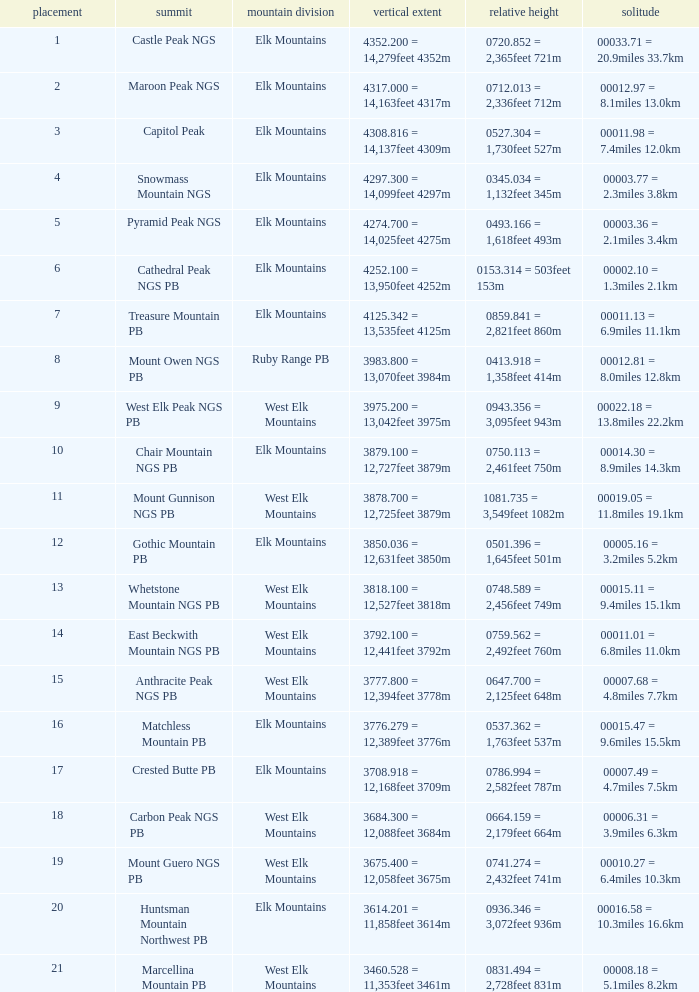Name the Rank of Rank Mountain Peak of crested butte pb? 17.0. 